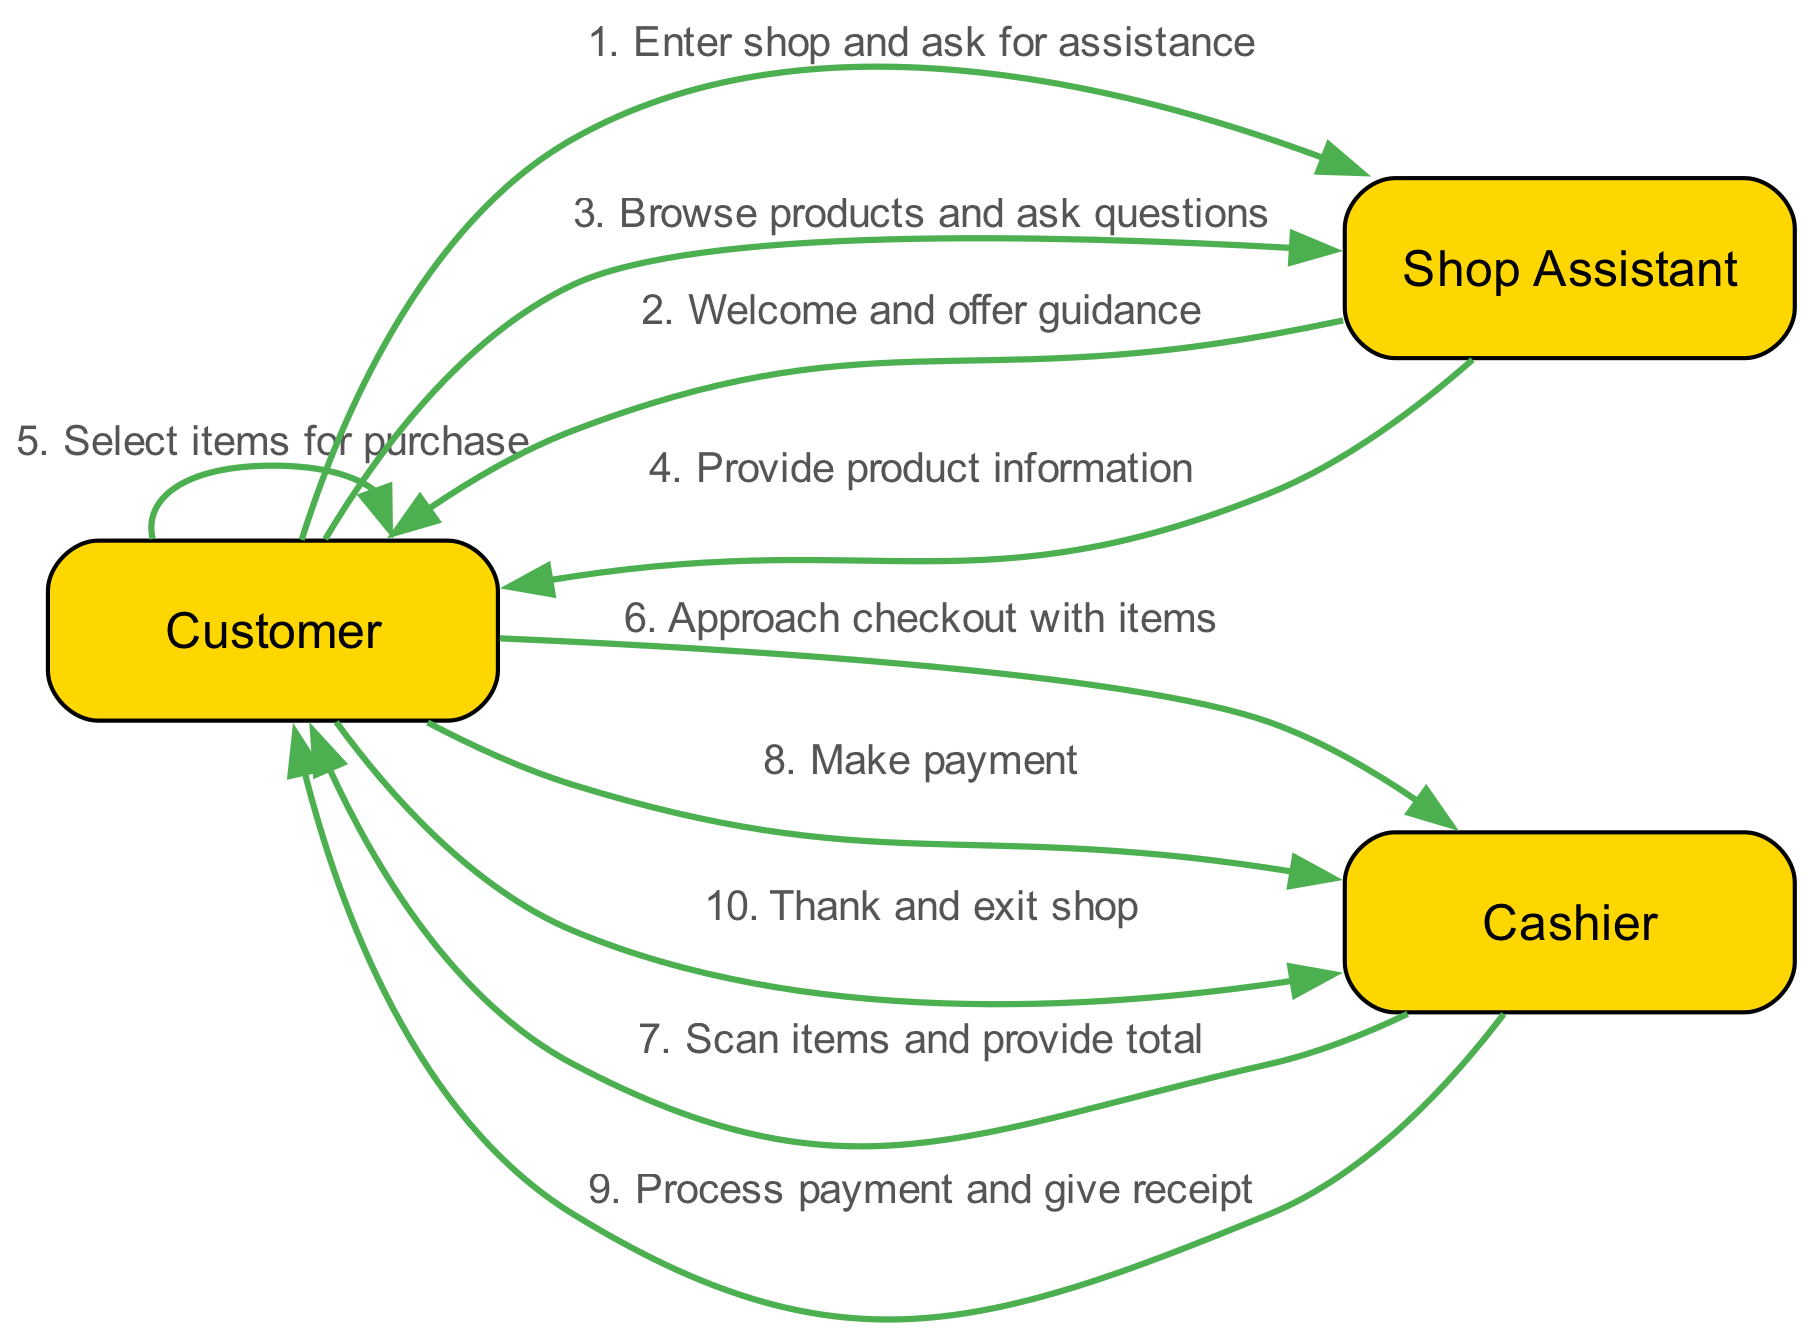What is the first action taken by the Customer? The diagram indicates that the first action taken by the Customer is to "Enter shop and ask for assistance" directed to the Shop Assistant.
Answer: Enter shop and ask for assistance How many actors are involved in the purchase journey? By counting the distinct entries in the "actors" section of the diagram, we see there are three individuals: Customer, Shop Assistant, and Cashier.
Answer: 3 Which actor provides product information? From the flow of actions, it is clear that the Shop Assistant is responsible for providing product information to the Customer.
Answer: Shop Assistant What action follows the Customer selecting items? According to the sequence, after the Customer selects items for purchase, the next action is to "Approach checkout with items" directed to the Cashier.
Answer: Approach checkout with items How many actions are performed by the Cashier in total? By reviewing the sequence, we note that the Cashier performs three actions: scanning items, processing payment, and giving a receipt.
Answer: 3 What is the final action taken by the Customer? The last action in the sequence indicates that the Customer thanks the Cashier and exits the shop.
Answer: Thank and exit shop Which action is performed directly after the Shop Assistant welcomes the Customer? Following the welcome from the Shop Assistant, the Customer then browses products and asks questions, as listed in the sequence.
Answer: Browse products and ask questions What relationship can be inferred between the Customer and the Cashier's actions? The relationship is sequential; the Customer approaches the Cashier after selecting items, and the Cashier's actions are dependent on that approach to complete the transaction.
Answer: Sequential relationship How many steps are there in the transaction from entering the shop to exiting? Counting each unique action in the sequence from the moment the Customer enters the shop until they exit indicates there are ten steps in total.
Answer: 10 